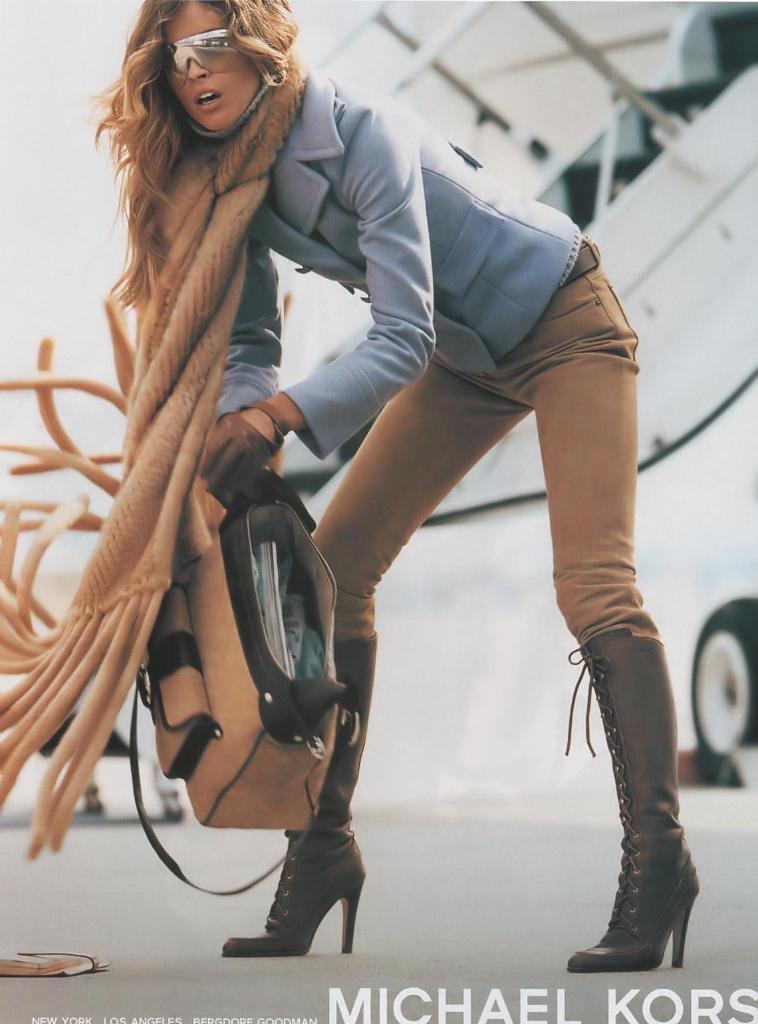Describe this image in one or two sentences. In this image I can see a person standing holding a bag. The person is wearing blue shirt, cream pant and the background is in white color. 